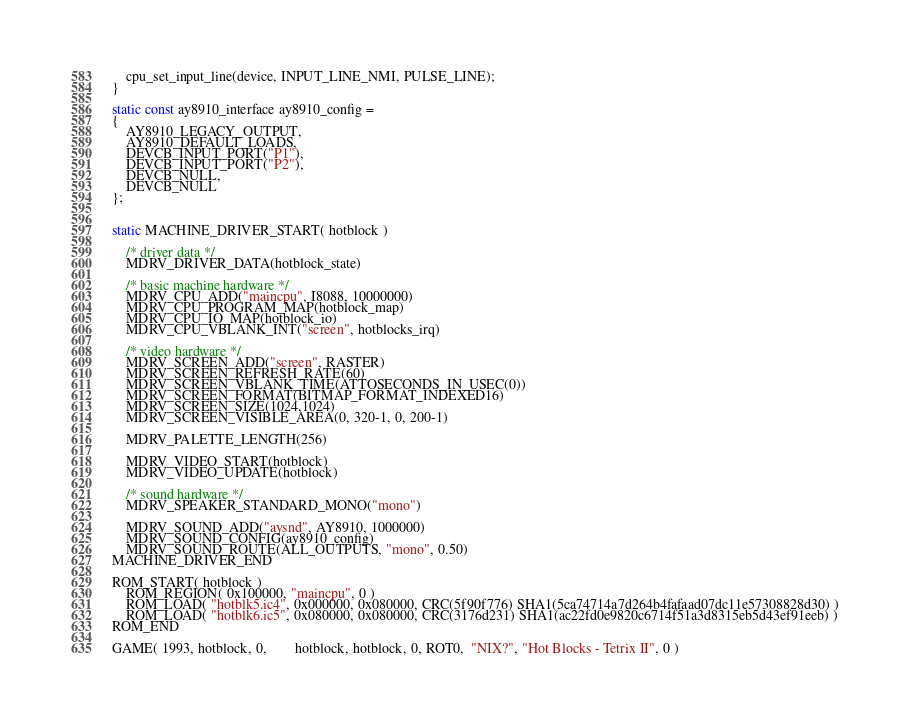Convert code to text. <code><loc_0><loc_0><loc_500><loc_500><_C_>	cpu_set_input_line(device, INPUT_LINE_NMI, PULSE_LINE);
}

static const ay8910_interface ay8910_config =
{
	AY8910_LEGACY_OUTPUT,
	AY8910_DEFAULT_LOADS,
	DEVCB_INPUT_PORT("P1"),
	DEVCB_INPUT_PORT("P2"),
	DEVCB_NULL,
	DEVCB_NULL
};


static MACHINE_DRIVER_START( hotblock )

	/* driver data */
	MDRV_DRIVER_DATA(hotblock_state)

	/* basic machine hardware */
	MDRV_CPU_ADD("maincpu", I8088, 10000000)
	MDRV_CPU_PROGRAM_MAP(hotblock_map)
	MDRV_CPU_IO_MAP(hotblock_io)
	MDRV_CPU_VBLANK_INT("screen", hotblocks_irq)

	/* video hardware */
	MDRV_SCREEN_ADD("screen", RASTER)
	MDRV_SCREEN_REFRESH_RATE(60)
	MDRV_SCREEN_VBLANK_TIME(ATTOSECONDS_IN_USEC(0))
	MDRV_SCREEN_FORMAT(BITMAP_FORMAT_INDEXED16)
	MDRV_SCREEN_SIZE(1024,1024)
	MDRV_SCREEN_VISIBLE_AREA(0, 320-1, 0, 200-1)

	MDRV_PALETTE_LENGTH(256)

	MDRV_VIDEO_START(hotblock)
	MDRV_VIDEO_UPDATE(hotblock)

	/* sound hardware */
	MDRV_SPEAKER_STANDARD_MONO("mono")

	MDRV_SOUND_ADD("aysnd", AY8910, 1000000)
	MDRV_SOUND_CONFIG(ay8910_config)
	MDRV_SOUND_ROUTE(ALL_OUTPUTS, "mono", 0.50)
MACHINE_DRIVER_END

ROM_START( hotblock )
	ROM_REGION( 0x100000, "maincpu", 0 )
	ROM_LOAD( "hotblk5.ic4", 0x000000, 0x080000, CRC(5f90f776) SHA1(5ca74714a7d264b4fafaad07dc11e57308828d30) )
	ROM_LOAD( "hotblk6.ic5", 0x080000, 0x080000, CRC(3176d231) SHA1(ac22fd0e9820c6714f51a3d8315eb5d43ef91eeb) )
ROM_END

GAME( 1993, hotblock, 0,        hotblock, hotblock, 0, ROT0,  "NIX?", "Hot Blocks - Tetrix II", 0 )
</code> 